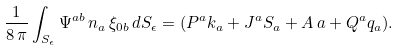<formula> <loc_0><loc_0><loc_500><loc_500>\frac { 1 } { 8 \, \pi } \int _ { S _ { \epsilon } } \Psi ^ { a b } \, n _ { a } \, \xi _ { 0 b } \, d S _ { \epsilon } = ( P ^ { a } k _ { a } + J ^ { a } S _ { a } + A \, a + Q ^ { a } q _ { a } ) .</formula> 